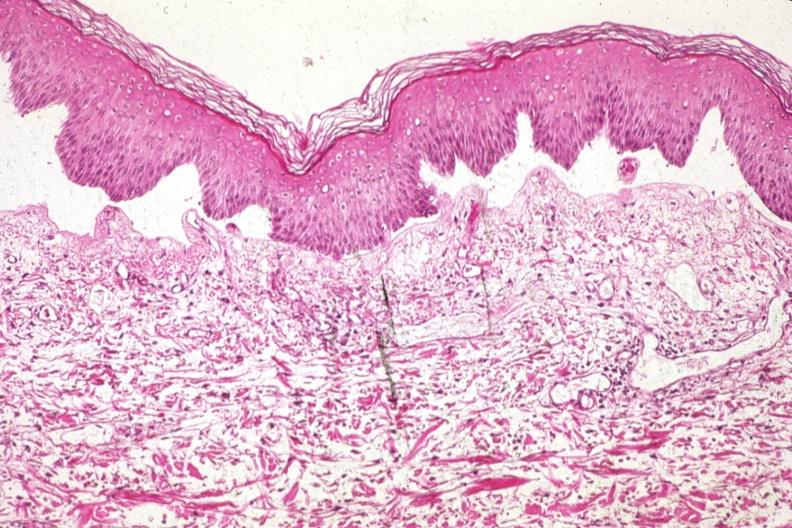s myocardial infarct 907?
Answer the question using a single word or phrase. No 